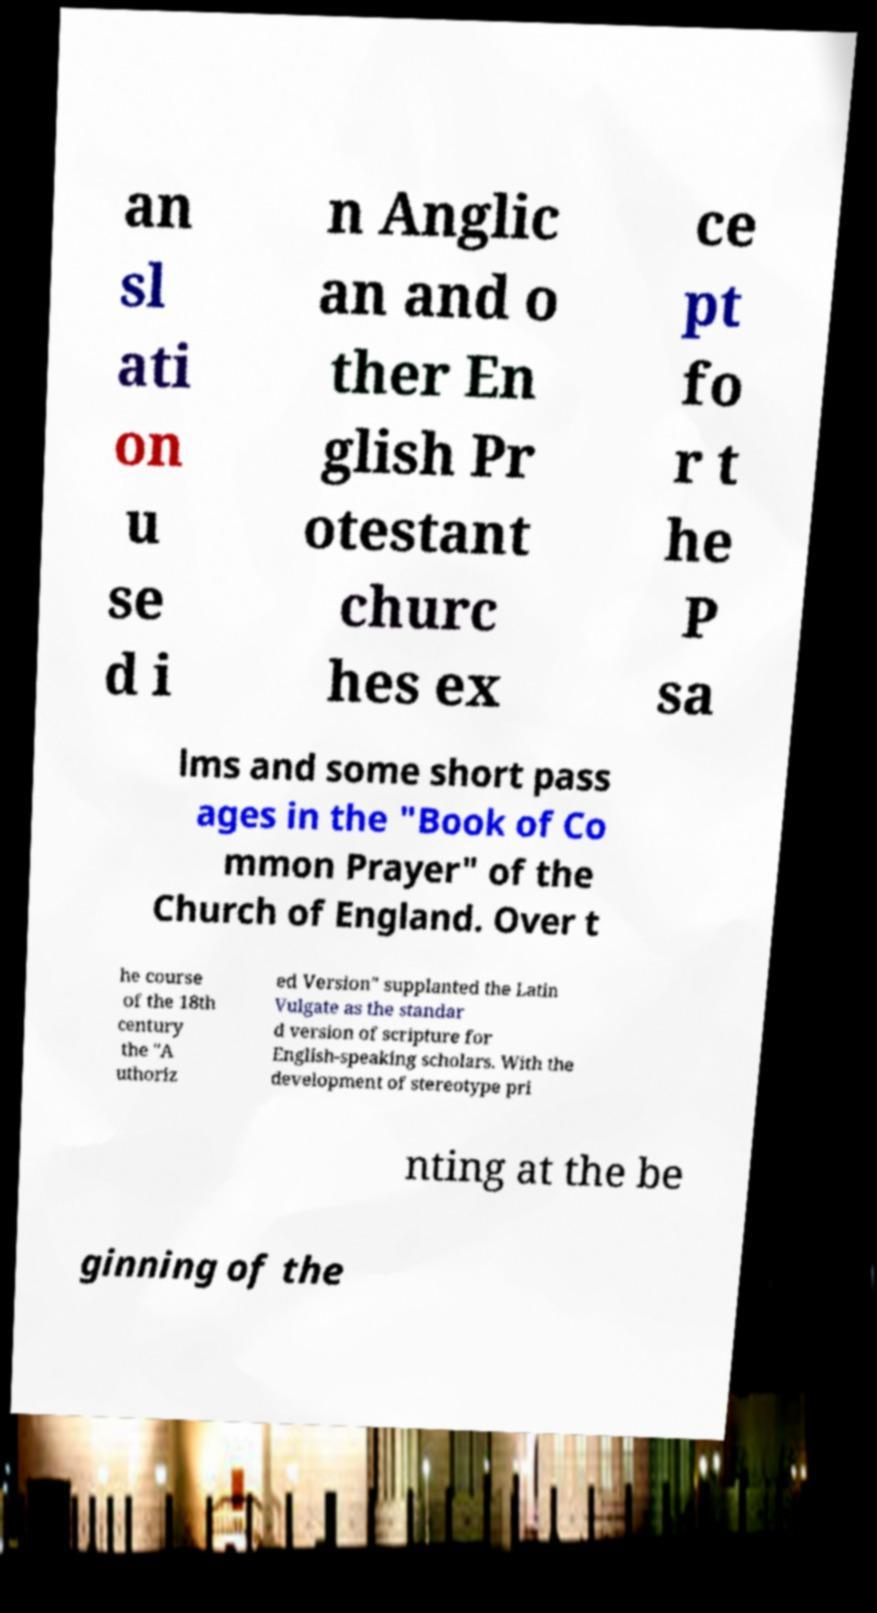There's text embedded in this image that I need extracted. Can you transcribe it verbatim? an sl ati on u se d i n Anglic an and o ther En glish Pr otestant churc hes ex ce pt fo r t he P sa lms and some short pass ages in the "Book of Co mmon Prayer" of the Church of England. Over t he course of the 18th century the "A uthoriz ed Version" supplanted the Latin Vulgate as the standar d version of scripture for English-speaking scholars. With the development of stereotype pri nting at the be ginning of the 